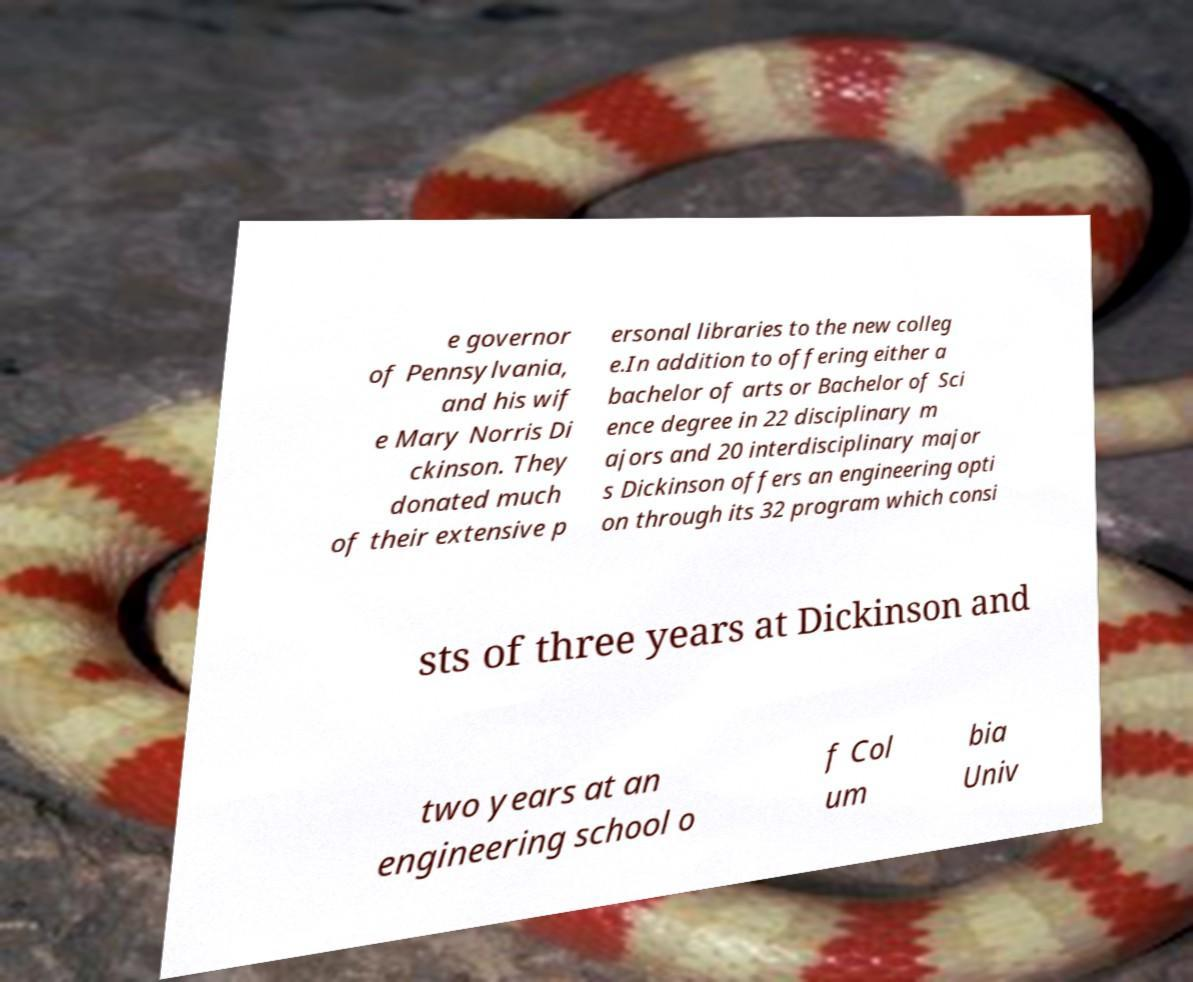Can you read and provide the text displayed in the image?This photo seems to have some interesting text. Can you extract and type it out for me? e governor of Pennsylvania, and his wif e Mary Norris Di ckinson. They donated much of their extensive p ersonal libraries to the new colleg e.In addition to offering either a bachelor of arts or Bachelor of Sci ence degree in 22 disciplinary m ajors and 20 interdisciplinary major s Dickinson offers an engineering opti on through its 32 program which consi sts of three years at Dickinson and two years at an engineering school o f Col um bia Univ 